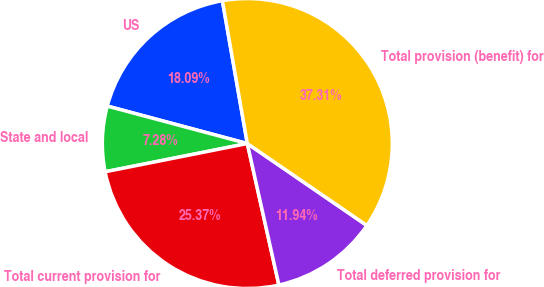<chart> <loc_0><loc_0><loc_500><loc_500><pie_chart><fcel>US<fcel>State and local<fcel>Total current provision for<fcel>Total deferred provision for<fcel>Total provision (benefit) for<nl><fcel>18.09%<fcel>7.28%<fcel>25.37%<fcel>11.94%<fcel>37.31%<nl></chart> 